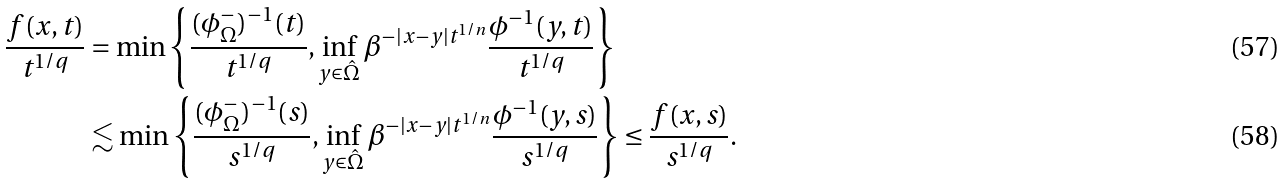Convert formula to latex. <formula><loc_0><loc_0><loc_500><loc_500>\frac { f ( x , t ) } { t ^ { 1 / q } } & = \min \left \{ \frac { ( \phi ^ { - } _ { \Omega } ) ^ { - 1 } ( t ) } { t ^ { 1 / q } } , \inf _ { y \in \hat { \Omega } } \beta ^ { - | x - y | t ^ { 1 / n } } \frac { \phi ^ { - 1 } ( y , t ) } { t ^ { 1 / q } } \right \} \\ & \lesssim \min \left \{ \frac { ( \phi ^ { - } _ { \Omega } ) ^ { - 1 } ( s ) } { s ^ { 1 / q } } , \inf _ { y \in \hat { \Omega } } \beta ^ { - | x - y | t ^ { 1 / n } } \frac { \phi ^ { - 1 } ( y , s ) } { s ^ { 1 / q } } \right \} \leq \frac { f ( x , s ) } { s ^ { 1 / q } } .</formula> 